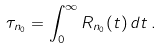<formula> <loc_0><loc_0><loc_500><loc_500>\tau _ { n _ { 0 } } = \int _ { 0 } ^ { \infty } R _ { n _ { 0 } } ( t ) \, d t \, .</formula> 